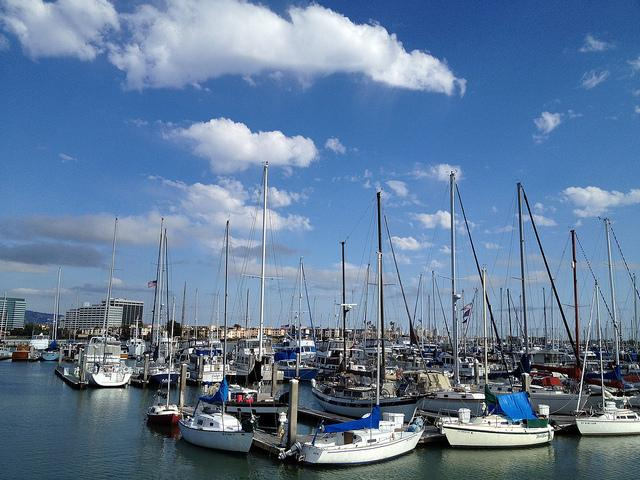Which object on one of the boats would help someone prepare for rain? tarp 